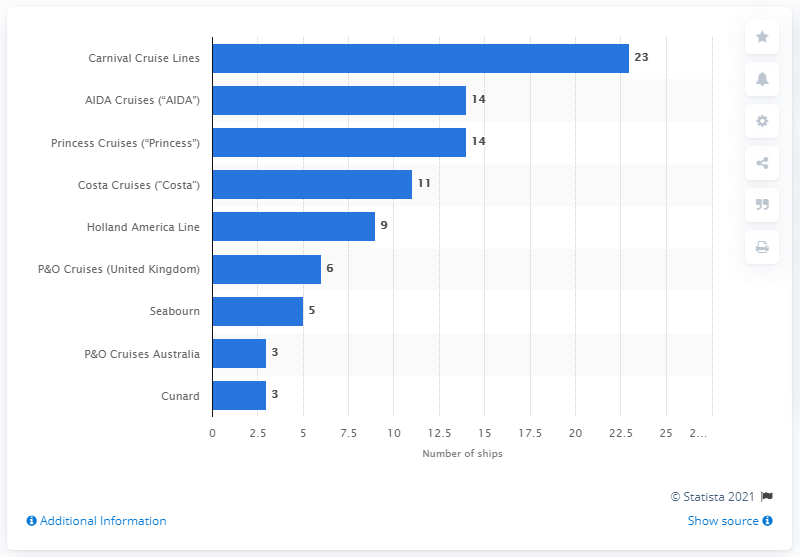Outline some significant characteristics in this image. As of November 30, 2020, Carnival Cruise Lines had the highest number of ships worldwide among all cruise lines. As of November 30, 2020, Carnival Cruise Lines had a total of 23 ships worldwide. As of today, AIDA Cruises and Princess Cruises have a combined total of 14 ships worldwide. 